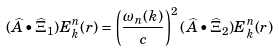Convert formula to latex. <formula><loc_0><loc_0><loc_500><loc_500>( \widehat { A } \bullet \widehat { \Xi } _ { 1 } ) E ^ { n } _ { k } ( r ) = \left ( \frac { \omega _ { n } ( k ) } { c } \right ) ^ { 2 } ( \widehat { A } \bullet \widehat { \Xi } _ { 2 } ) E ^ { n } _ { k } ( r )</formula> 